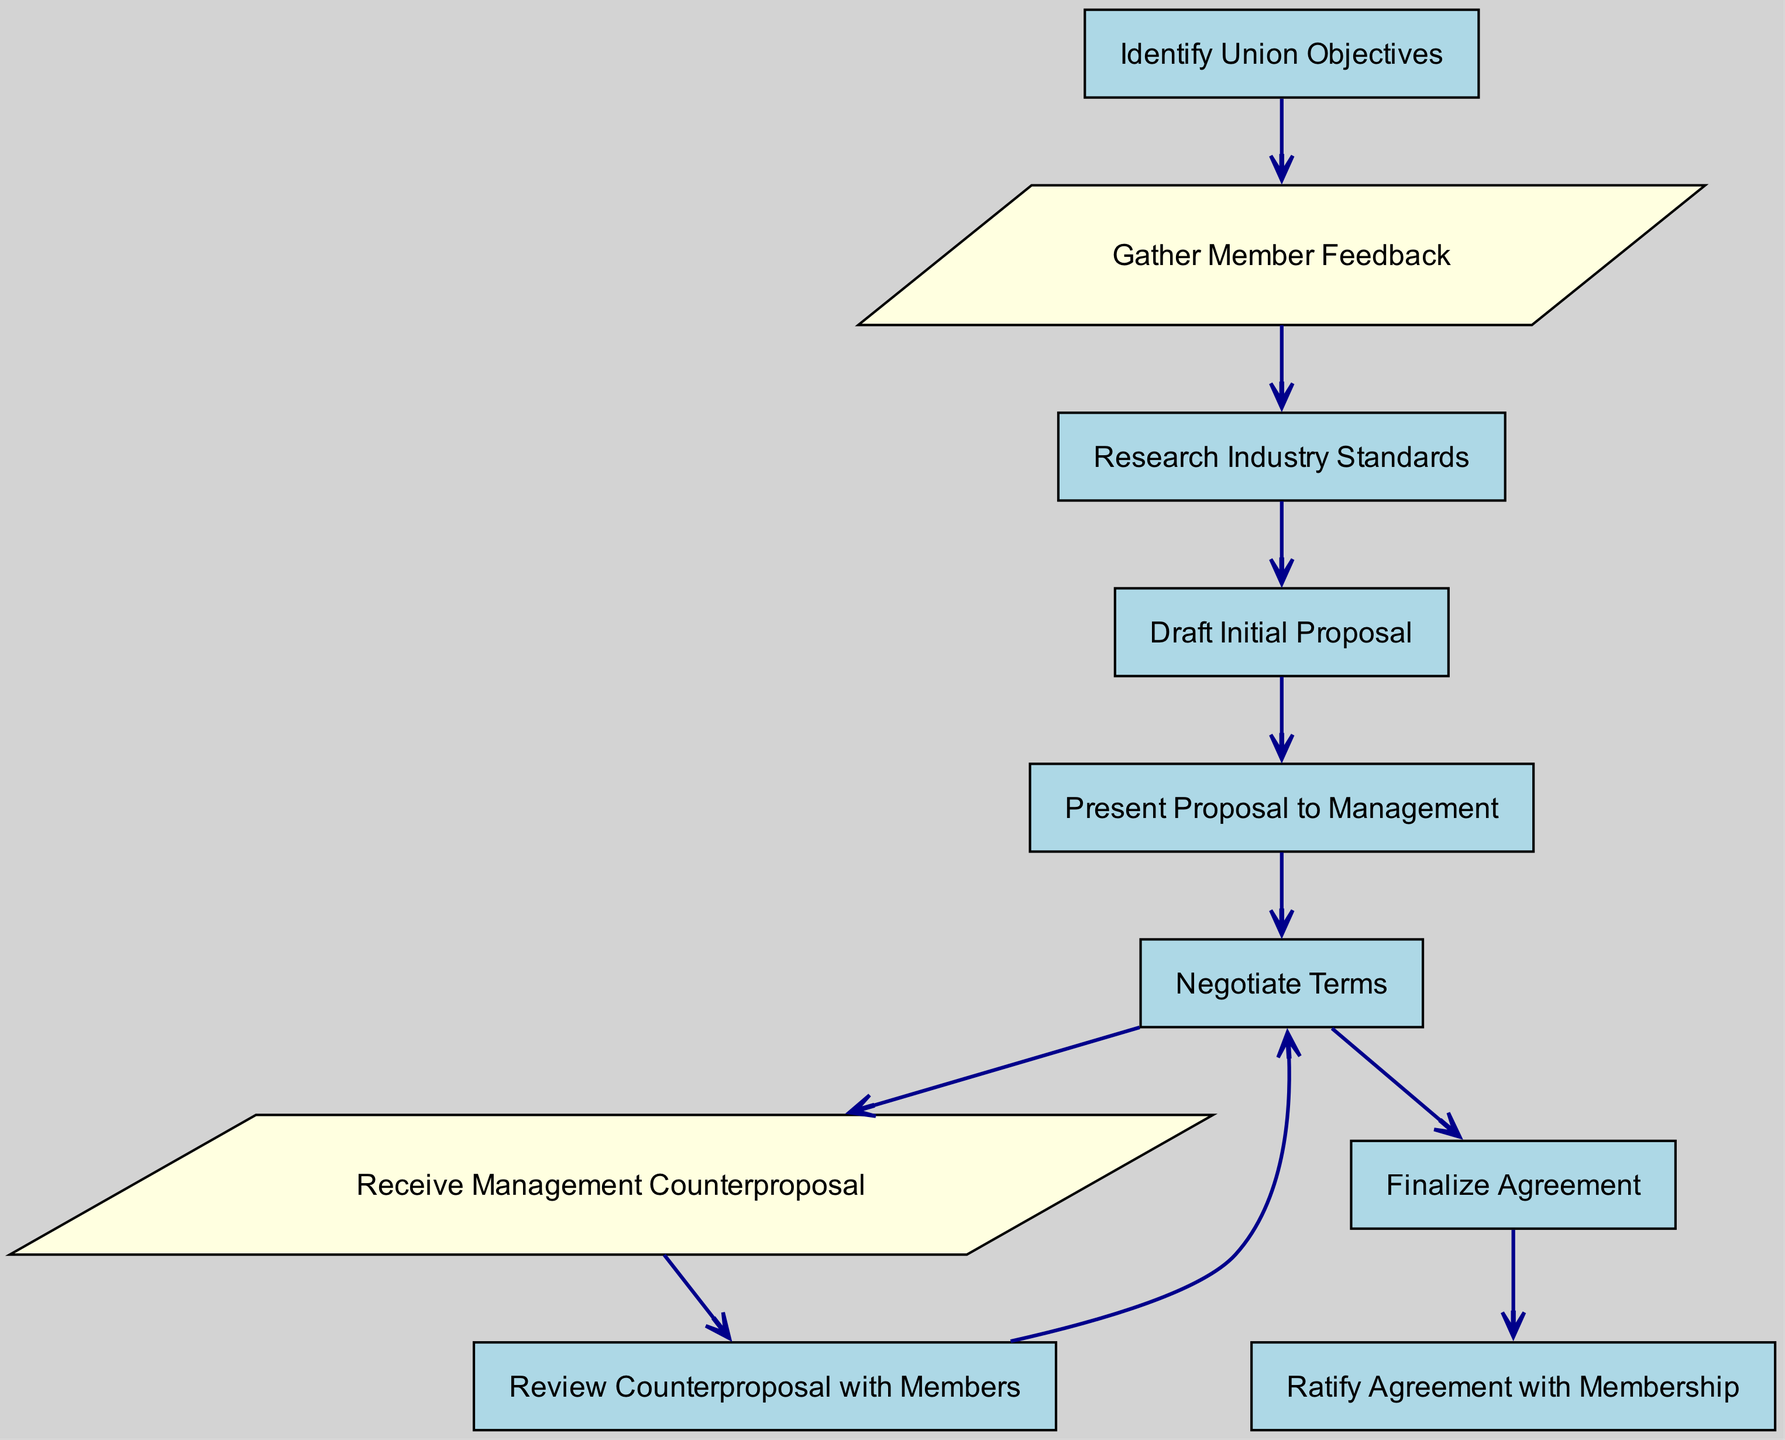What is the first step in the negotiation process? The first step in the negotiation process is to identify union objectives, which is the starting node in the diagram.
Answer: Identify Union Objectives How many process nodes are in the diagram? By counting the nodes specifically marked as "Process," we find there are six process nodes in total.
Answer: 6 What type of input is received after negotiating terms? After the negotiating terms process, the input received is a management counterproposal, which is explicitly shown in the diagram.
Answer: Receive Management Counterproposal Which node follows the "Present Proposal to Management" node? According to the flow of the diagram, the node that follows "Present Proposal to Management" is "Negotiate Terms," as it is directly connected.
Answer: Negotiate Terms What action occurs after reviewing the counterproposal with members? The action that occurs after reviewing the counterproposal with members is negotiating terms again, indicating a feedback loop in the process.
Answer: Negotiate Terms How many edges connect the nodes in the diagram? By counting all the directed connections (edges) between the nodes, we find there are nine edges total in the diagram.
Answer: 9 What is the last step in finalizing the agreement? The last step in finalizing the agreement is to ratify the agreement with membership, as depicted at the end of the flowchart.
Answer: Ratify Agreement with Membership What is the relationship between "Gather Member Feedback" and "Research Industry Standards"? "Gather Member Feedback" leads directly to "Research Industry Standards," indicating that member feedback informs industry research.
Answer: Direct connection What type of shape represents the input nodes in the diagram? The input nodes in the diagram are represented by a parallelogram shape, which is standard for input nodes in flowcharts.
Answer: Parallelogram 